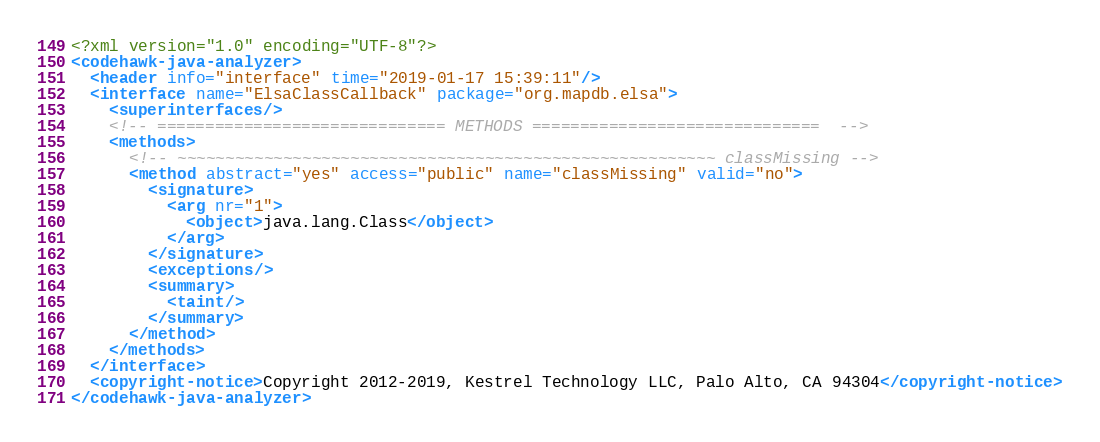<code> <loc_0><loc_0><loc_500><loc_500><_XML_><?xml version="1.0" encoding="UTF-8"?>
<codehawk-java-analyzer>
  <header info="interface" time="2019-01-17 15:39:11"/>
  <interface name="ElsaClassCallback" package="org.mapdb.elsa">
    <superinterfaces/>
    <!-- ============================== METHODS ==============================  -->
    <methods>
      <!-- ~~~~~~~~~~~~~~~~~~~~~~~~~~~~~~~~~~~~~~~~~~~~~~~~~~~~~~~~ classMissing -->
      <method abstract="yes" access="public" name="classMissing" valid="no">
        <signature>
          <arg nr="1">
            <object>java.lang.Class</object>
          </arg>
        </signature>
        <exceptions/>
        <summary>
          <taint/>
        </summary>
      </method>
    </methods>
  </interface>
  <copyright-notice>Copyright 2012-2019, Kestrel Technology LLC, Palo Alto, CA 94304</copyright-notice>
</codehawk-java-analyzer>
</code> 